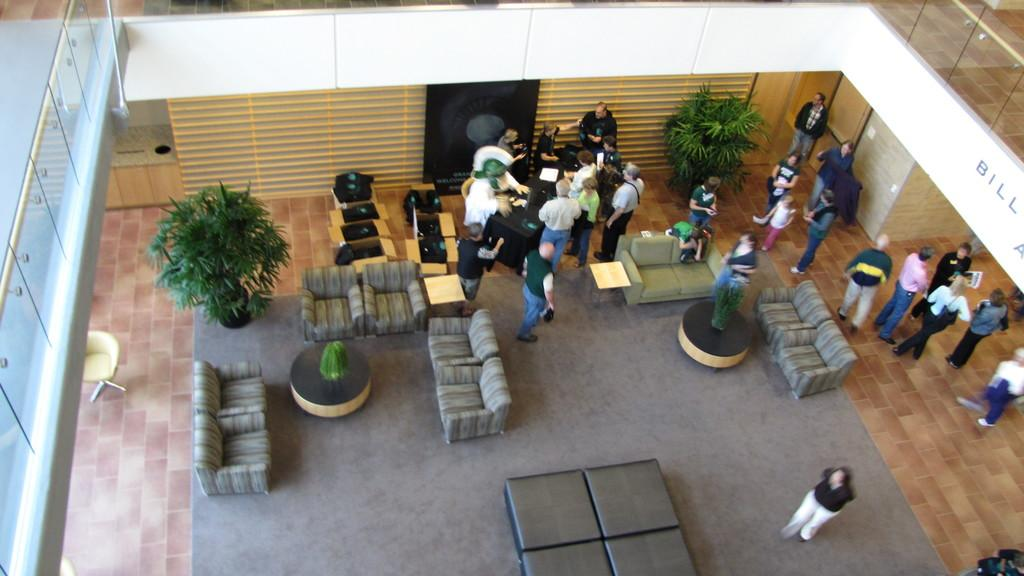What can be seen in the image? There are persons standing in the image. What type of furniture is present in the image? There are sofas in the image. What statement is being made by the persons in the image? There is no statement being made by the persons in the image; we can only observe their presence and actions. Can you provide a receipt for the sofas in the image? There is no receipt for the sofas in the image, as it is a photograph and not a purchase record. 